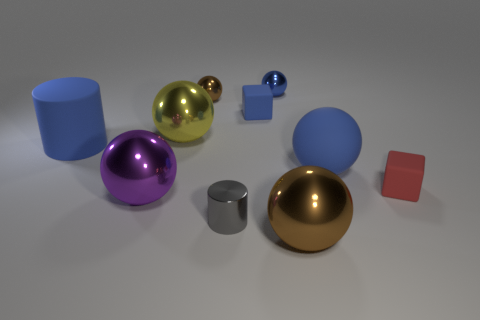What is the shape of the tiny object that is both in front of the yellow object and to the left of the small red block?
Provide a short and direct response. Cylinder. Are there more brown shiny objects that are on the right side of the tiny brown metallic object than big purple objects?
Your answer should be compact. No. What is the size of the purple object that is made of the same material as the yellow thing?
Offer a terse response. Large. How many tiny metal balls are the same color as the large cylinder?
Provide a succinct answer. 1. Is the color of the small matte block that is left of the large brown shiny sphere the same as the matte cylinder?
Your answer should be very brief. Yes. Are there an equal number of tiny blue metallic spheres that are in front of the yellow ball and rubber blocks behind the red rubber object?
Make the answer very short. No. Are there any other things that have the same material as the tiny blue sphere?
Give a very brief answer. Yes. What color is the large shiny sphere that is in front of the small gray metallic object?
Keep it short and to the point. Brown. Are there the same number of tiny gray cylinders behind the purple shiny thing and big blue cylinders?
Ensure brevity in your answer.  No. How many other things are the same shape as the tiny blue metallic thing?
Give a very brief answer. 5. 